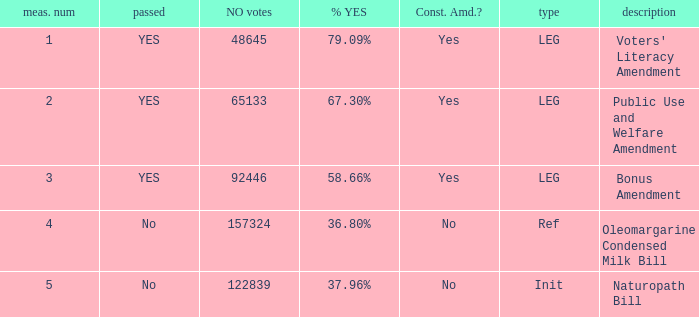What is the measurement figure for the init type? 5.0. Write the full table. {'header': ['meas. num', 'passed', 'NO votes', '% YES', 'Const. Amd.?', 'type', 'description'], 'rows': [['1', 'YES', '48645', '79.09%', 'Yes', 'LEG', "Voters' Literacy Amendment"], ['2', 'YES', '65133', '67.30%', 'Yes', 'LEG', 'Public Use and Welfare Amendment'], ['3', 'YES', '92446', '58.66%', 'Yes', 'LEG', 'Bonus Amendment'], ['4', 'No', '157324', '36.80%', 'No', 'Ref', 'Oleomargarine Condensed Milk Bill'], ['5', 'No', '122839', '37.96%', 'No', 'Init', 'Naturopath Bill']]} 